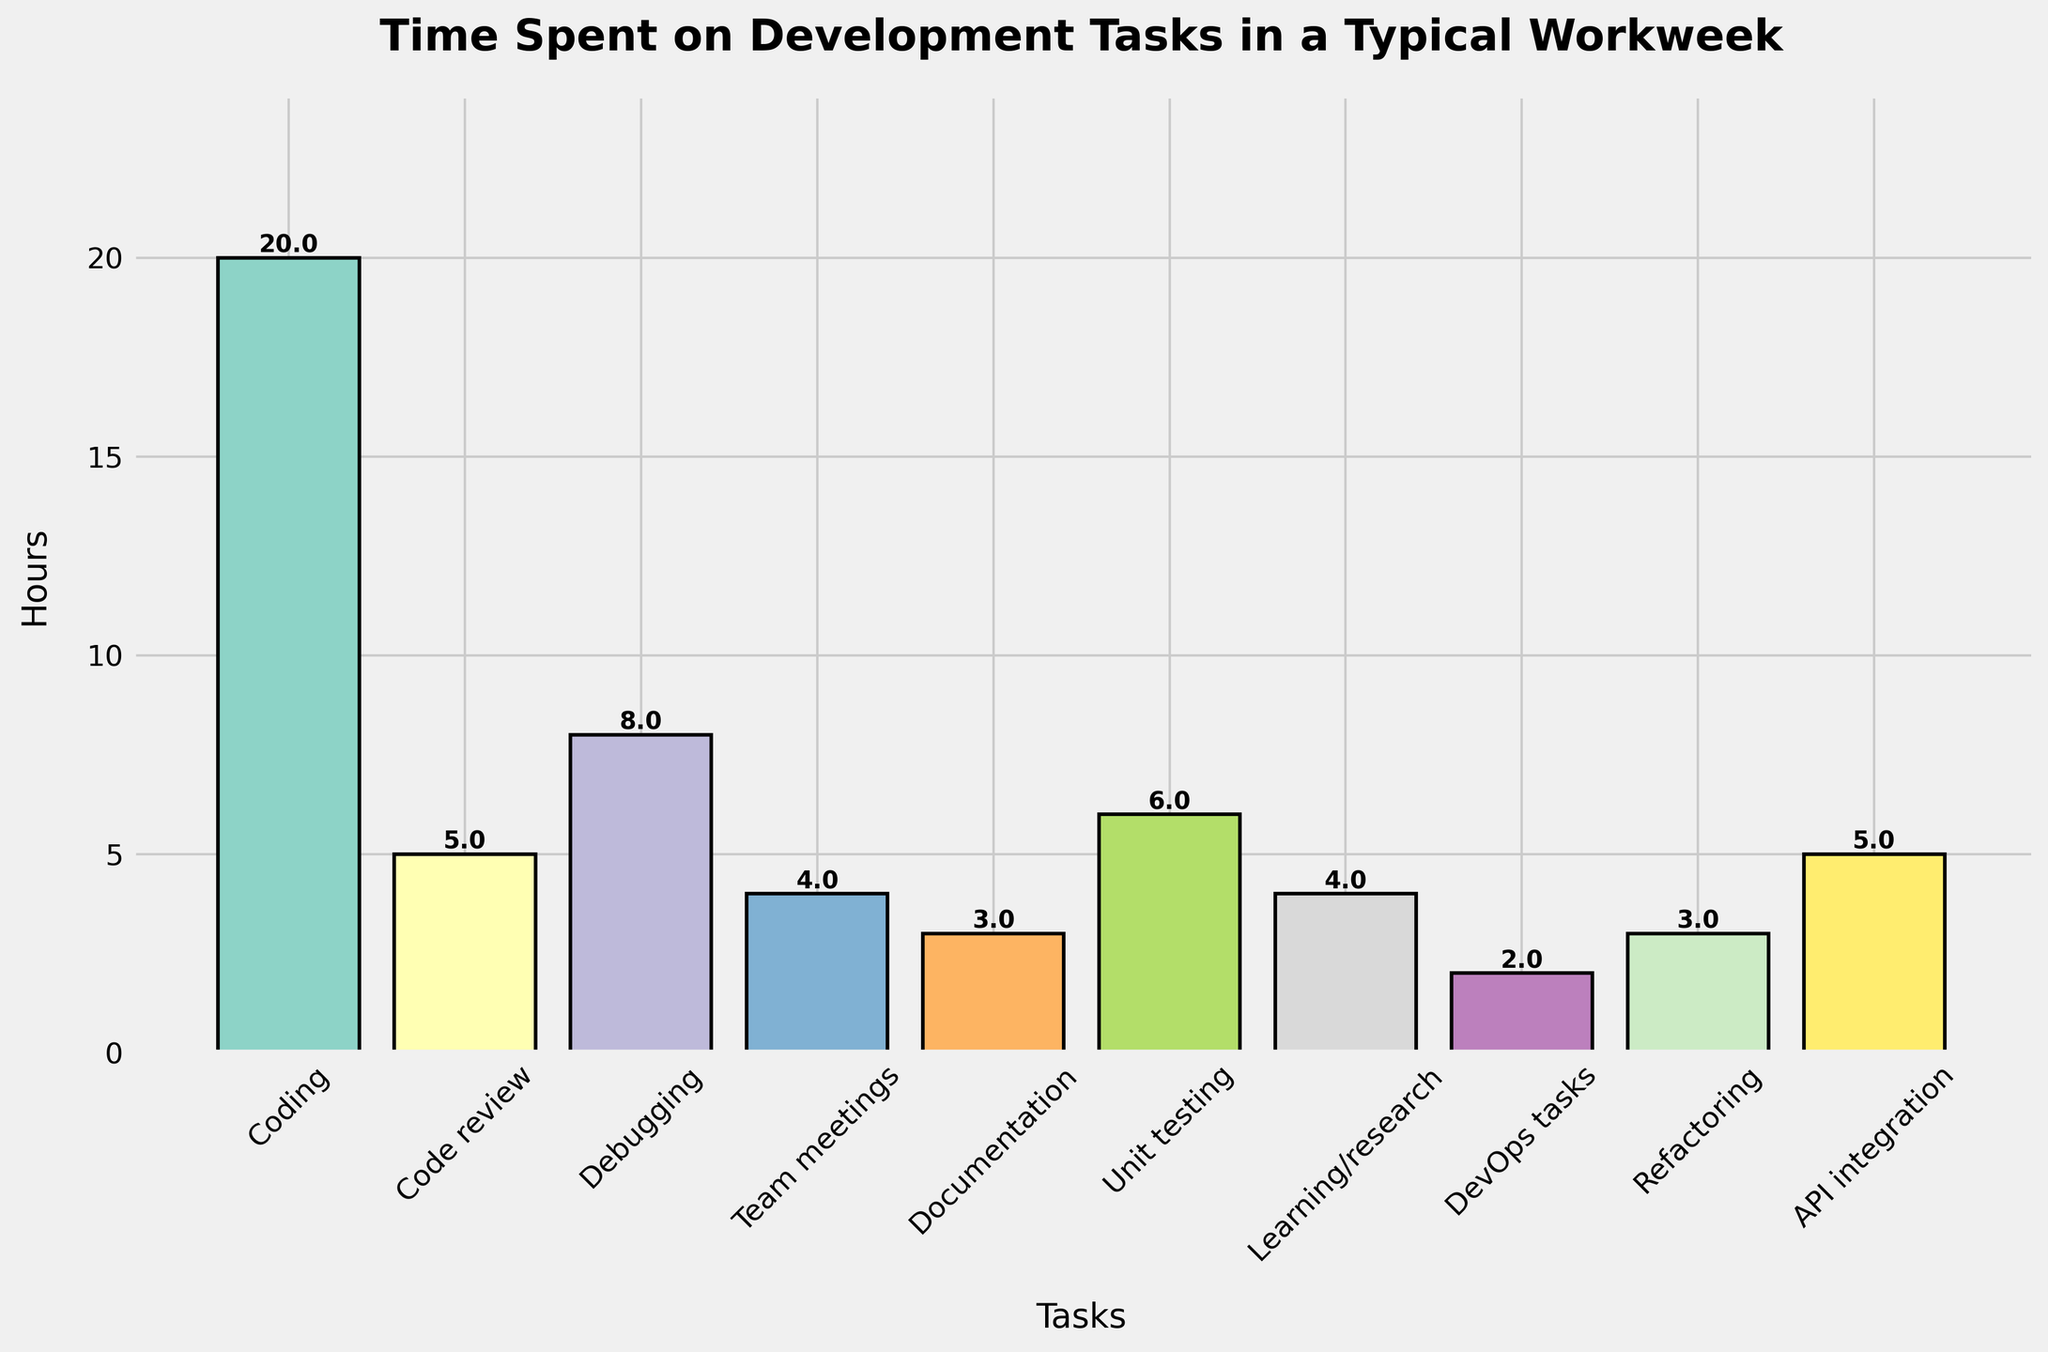What's the total time spent on coding and code review tasks? The time spent on coding is 20 hours, and the time spent on code review is 5 hours. Adding them together gives 20 + 5 = 25 hours.
Answer: 25 hours Which task has the lowest number of hours? We can see that the task with the shortest bar is DevOps tasks, which has 2 hours allocated.
Answer: DevOps tasks How much more time is spent on debugging than on team meetings? The time spent on debugging is 8 hours, and the time spent on team meetings is 4 hours. The difference is 8 - 4 = 4 hours.
Answer: 4 hours What's the average time spent on unit testing, documentation, and learning/research? The time for unit testing is 6 hours, documentation is 3 hours, and learning/research is 4 hours. The average is calculated as (6 + 3 + 4) / 3 = 13 / 3 ≈ 4.33 hours.
Answer: 4.33 hours Which tasks take up the same amount of time? Both code review and API integration have bars of the same height, which represent 5 hours each.
Answer: Code review and API integration Calculate the sum of the hours spent on tasks with bars shorter than debugging. The tasks with bars shorter than debugging (8 hours) are code review (5 hours), team meetings (4 hours), documentation (3 hours), unit testing (6 hours), learning/research (4 hours), DevOps tasks (2 hours), refactoring (3 hours), and API integration (5 hours). The sum is 5 + 4 + 3 + 6 + 4 + 2 + 3 + 5 = 32 hours.
Answer: 32 hours Is more time spent on coding or the combination of team meetings and learning/research? Coding takes 20 hours. Team meetings and learning/research combined take 4 + 4 = 8 hours, which is less than 20 hours.
Answer: Coding By how much does the time spent on documentation exceed the time spent on DevOps tasks? Documentation takes 3 hours, while DevOps tasks take 2 hours. The difference is 3 - 2 = 1 hour.
Answer: 1 hour What is the total time spent across all tasks? Summing up all the hours: 20 (coding) + 5 (code review) + 8 (debugging) + 4 (team meetings) + 3 (documentation) + 6 (unit testing) + 4 (learning/research) + 2 (DevOps tasks) + 3 (refactoring) + 5 (API integration) = 60 hours.
Answer: 60 hours 